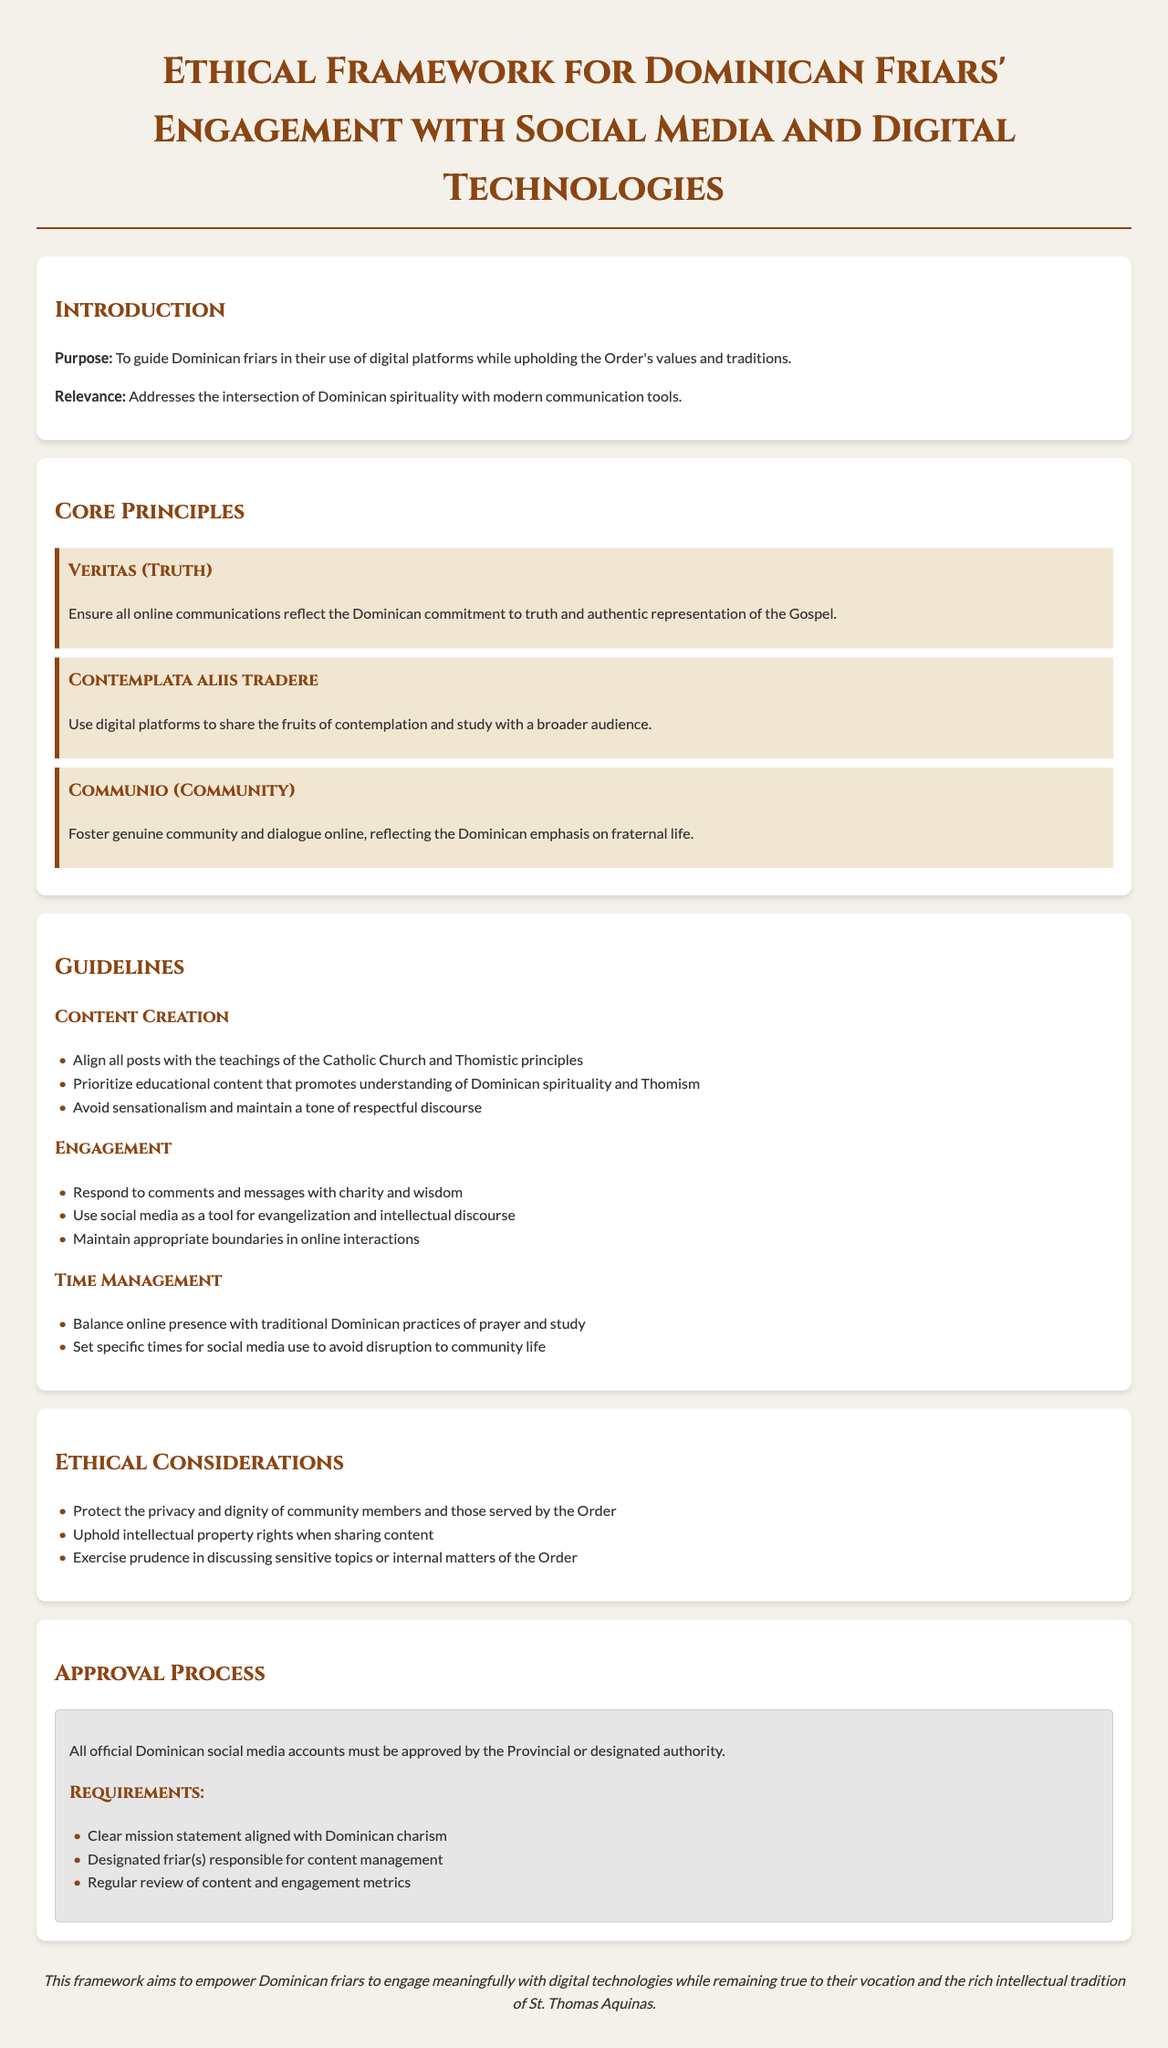What is the purpose of the document? The purpose is to guide Dominican friars in their use of digital platforms while upholding the Order's values and traditions.
Answer: To guide Dominican friars in their use of digital platforms while upholding the Order's values and traditions What are the three core principles outlined in the document? The core principles are Veritas, Contemplata aliis tradere, and Communio.
Answer: Veritas, Contemplata aliis tradere, Communio Who must approve all official Dominican social media accounts? The Provincial or designated authority must approve all official accounts.
Answer: The Provincial or designated authority What is one guideline regarding content creation? Content creation must align with the teachings of the Catholic Church and Thomistic principles.
Answer: Align all posts with the teachings of the Catholic Church and Thomistic principles What is required for the approval process of social media accounts? A clear mission statement aligned with Dominican charism is required.
Answer: Clear mission statement aligned with Dominican charism How should friars engage with comments and messages? Friars should respond to comments and messages with charity and wisdom.
Answer: With charity and wisdom What is emphasized for community life in terms of social media use? Balancing online presence with traditional Dominican practices is emphasized.
Answer: Balance online presence with traditional Dominican practices of prayer and study What does the conclusion state about the framework? It states that the framework aims to empower Dominican friars to engage meaningfully with digital technologies.
Answer: To empower Dominican friars to engage meaningfully with digital technologies 